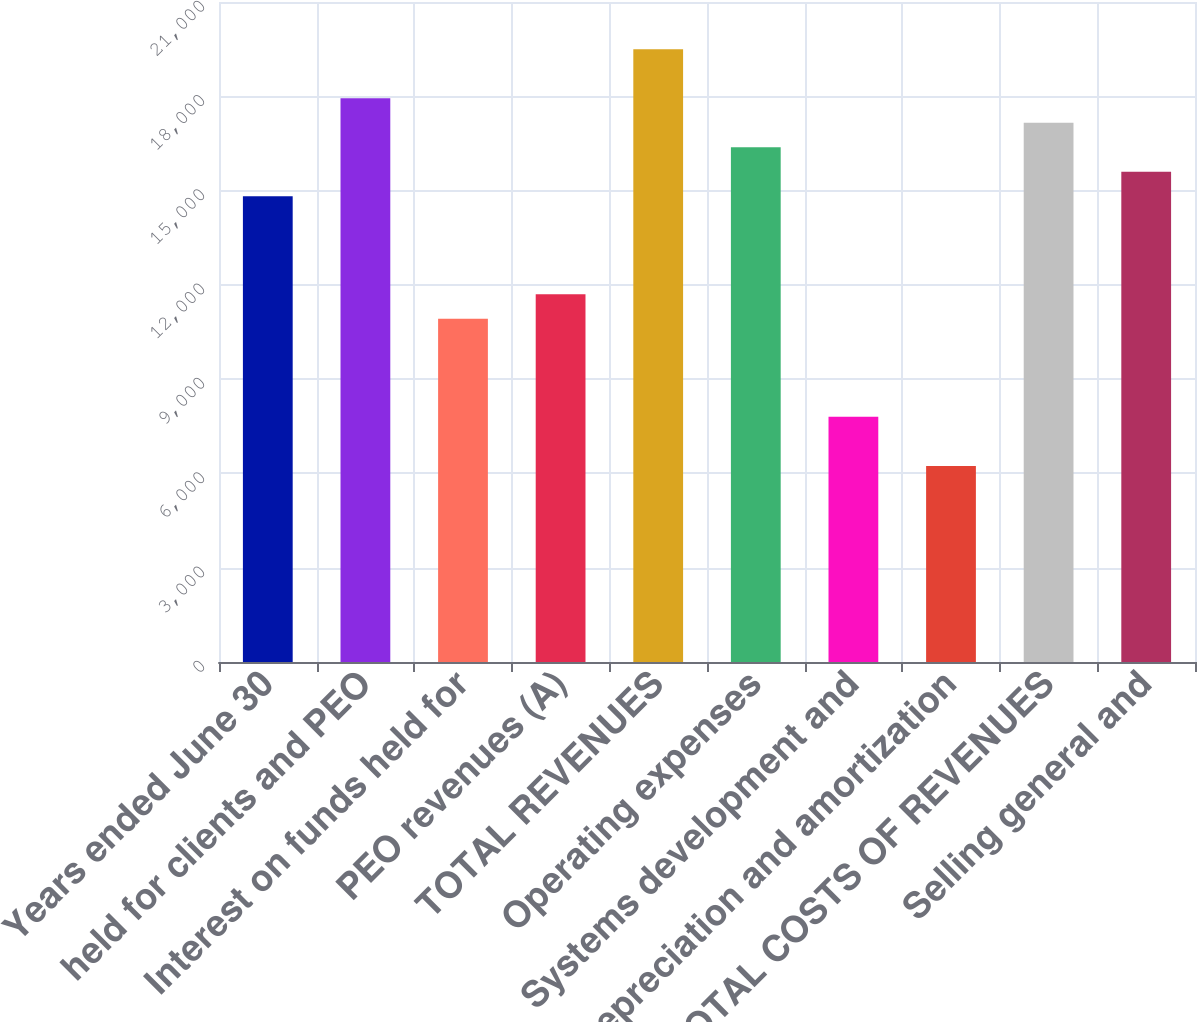<chart> <loc_0><loc_0><loc_500><loc_500><bar_chart><fcel>Years ended June 30<fcel>held for clients and PEO<fcel>Interest on funds held for<fcel>PEO revenues (A)<fcel>TOTAL REVENUES<fcel>Operating expenses<fcel>Systems development and<fcel>Depreciation and amortization<fcel>TOTAL COSTS OF REVENUES<fcel>Selling general and<nl><fcel>14819.8<fcel>17939.8<fcel>10919.9<fcel>11699.9<fcel>19499.7<fcel>16379.8<fcel>7800.01<fcel>6240.05<fcel>17159.8<fcel>15599.8<nl></chart> 